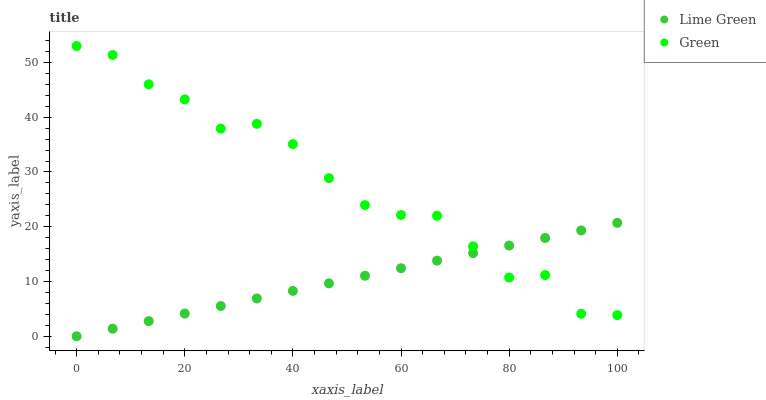Does Lime Green have the minimum area under the curve?
Answer yes or no. Yes. Does Green have the maximum area under the curve?
Answer yes or no. Yes. Does Lime Green have the maximum area under the curve?
Answer yes or no. No. Is Lime Green the smoothest?
Answer yes or no. Yes. Is Green the roughest?
Answer yes or no. Yes. Is Lime Green the roughest?
Answer yes or no. No. Does Lime Green have the lowest value?
Answer yes or no. Yes. Does Green have the highest value?
Answer yes or no. Yes. Does Lime Green have the highest value?
Answer yes or no. No. Does Lime Green intersect Green?
Answer yes or no. Yes. Is Lime Green less than Green?
Answer yes or no. No. Is Lime Green greater than Green?
Answer yes or no. No. 